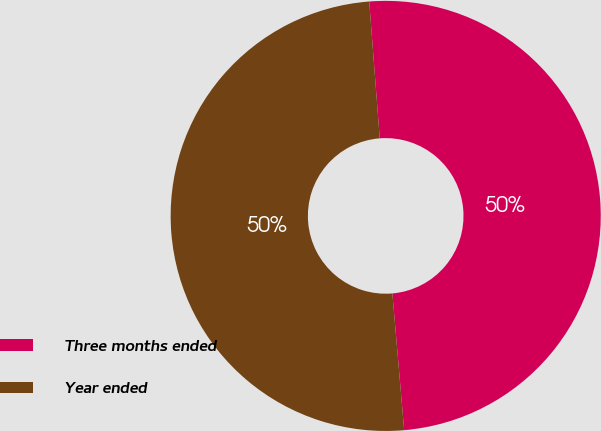Convert chart. <chart><loc_0><loc_0><loc_500><loc_500><pie_chart><fcel>Three months ended<fcel>Year ended<nl><fcel>49.85%<fcel>50.15%<nl></chart> 